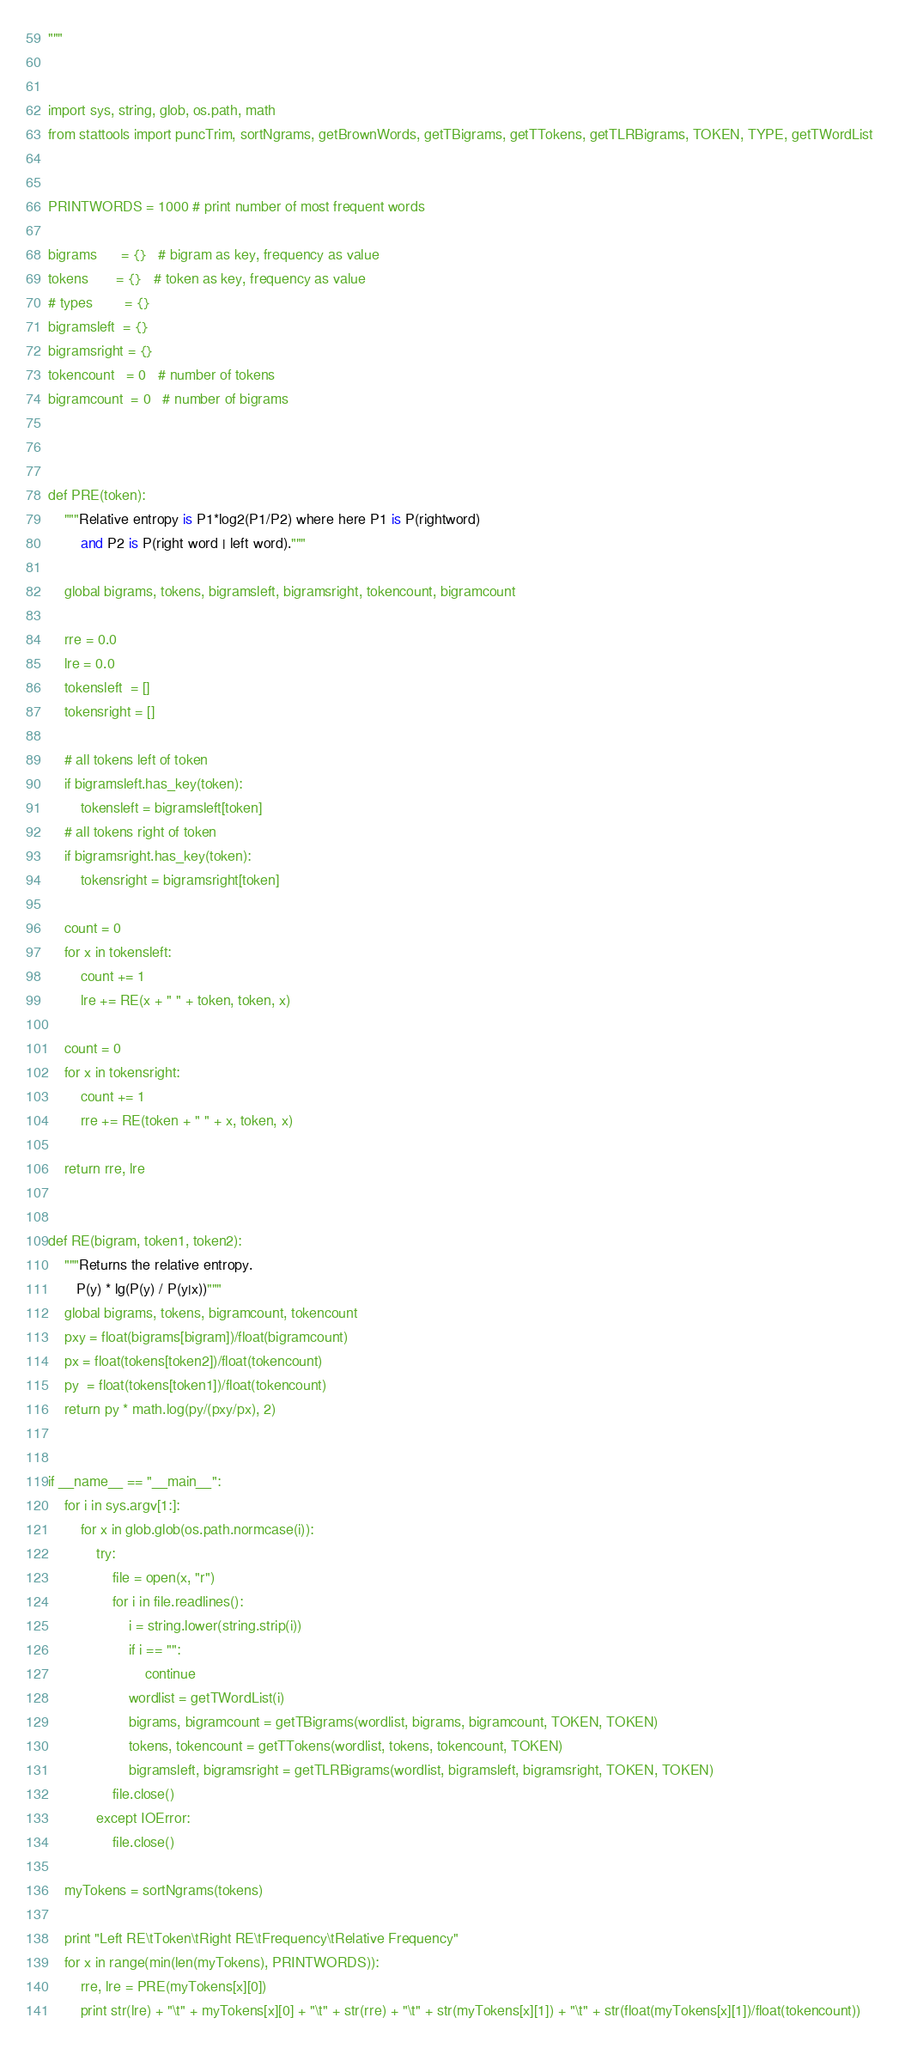Convert code to text. <code><loc_0><loc_0><loc_500><loc_500><_Python_>"""


import sys, string, glob, os.path, math
from stattools import puncTrim, sortNgrams, getBrownWords, getTBigrams, getTTokens, getTLRBigrams, TOKEN, TYPE, getTWordList


PRINTWORDS = 1000 # print number of most frequent words

bigrams      = {}	# bigram as key, frequency as value
tokens       = {}	# token as key, frequency as value
# types        = {}
bigramsleft  = {}
bigramsright = {}
tokencount   = 0   # number of tokens
bigramcount  = 0   # number of bigrams



def PRE(token):
	"""Relative entropy is P1*log2(P1/P2) where here P1 is P(rightword)
		and P2 is P(right word | left word)."""

	global bigrams, tokens, bigramsleft, bigramsright, tokencount, bigramcount

	rre = 0.0
	lre = 0.0
	tokensleft  = []
	tokensright = []

	# all tokens left of token
	if bigramsleft.has_key(token):
		tokensleft = bigramsleft[token]
	# all tokens right of token
	if bigramsright.has_key(token):
		tokensright = bigramsright[token]

	count = 0
	for x in tokensleft:
		count += 1
		lre += RE(x + " " + token, token, x)

	count = 0
	for x in tokensright:
		count += 1
		rre += RE(token + " " + x, token, x)

	return rre, lre


def RE(bigram, token1, token2):
	"""Returns the relative entropy.
	   P(y) * lg(P(y) / P(y|x))"""
	global bigrams, tokens, bigramcount, tokencount
	pxy = float(bigrams[bigram])/float(bigramcount)
	px = float(tokens[token2])/float(tokencount)
	py  = float(tokens[token1])/float(tokencount)
	return py * math.log(py/(pxy/px), 2)


if __name__ == "__main__":
	for i in sys.argv[1:]:
		for x in glob.glob(os.path.normcase(i)):
			try:
				file = open(x, "r")
				for i in file.readlines():
					i = string.lower(string.strip(i))
					if i == "":
						continue
					wordlist = getTWordList(i)
					bigrams, bigramcount = getTBigrams(wordlist, bigrams, bigramcount, TOKEN, TOKEN)
					tokens, tokencount = getTTokens(wordlist, tokens, tokencount, TOKEN)
					bigramsleft, bigramsright = getTLRBigrams(wordlist, bigramsleft, bigramsright, TOKEN, TOKEN)
				file.close()
			except IOError:
				file.close()

	myTokens = sortNgrams(tokens)

	print "Left RE\tToken\tRight RE\tFrequency\tRelative Frequency"
	for x in range(min(len(myTokens), PRINTWORDS)):
		rre, lre = PRE(myTokens[x][0])
		print str(lre) + "\t" + myTokens[x][0] + "\t" + str(rre) + "\t" + str(myTokens[x][1]) + "\t" + str(float(myTokens[x][1])/float(tokencount))
</code> 